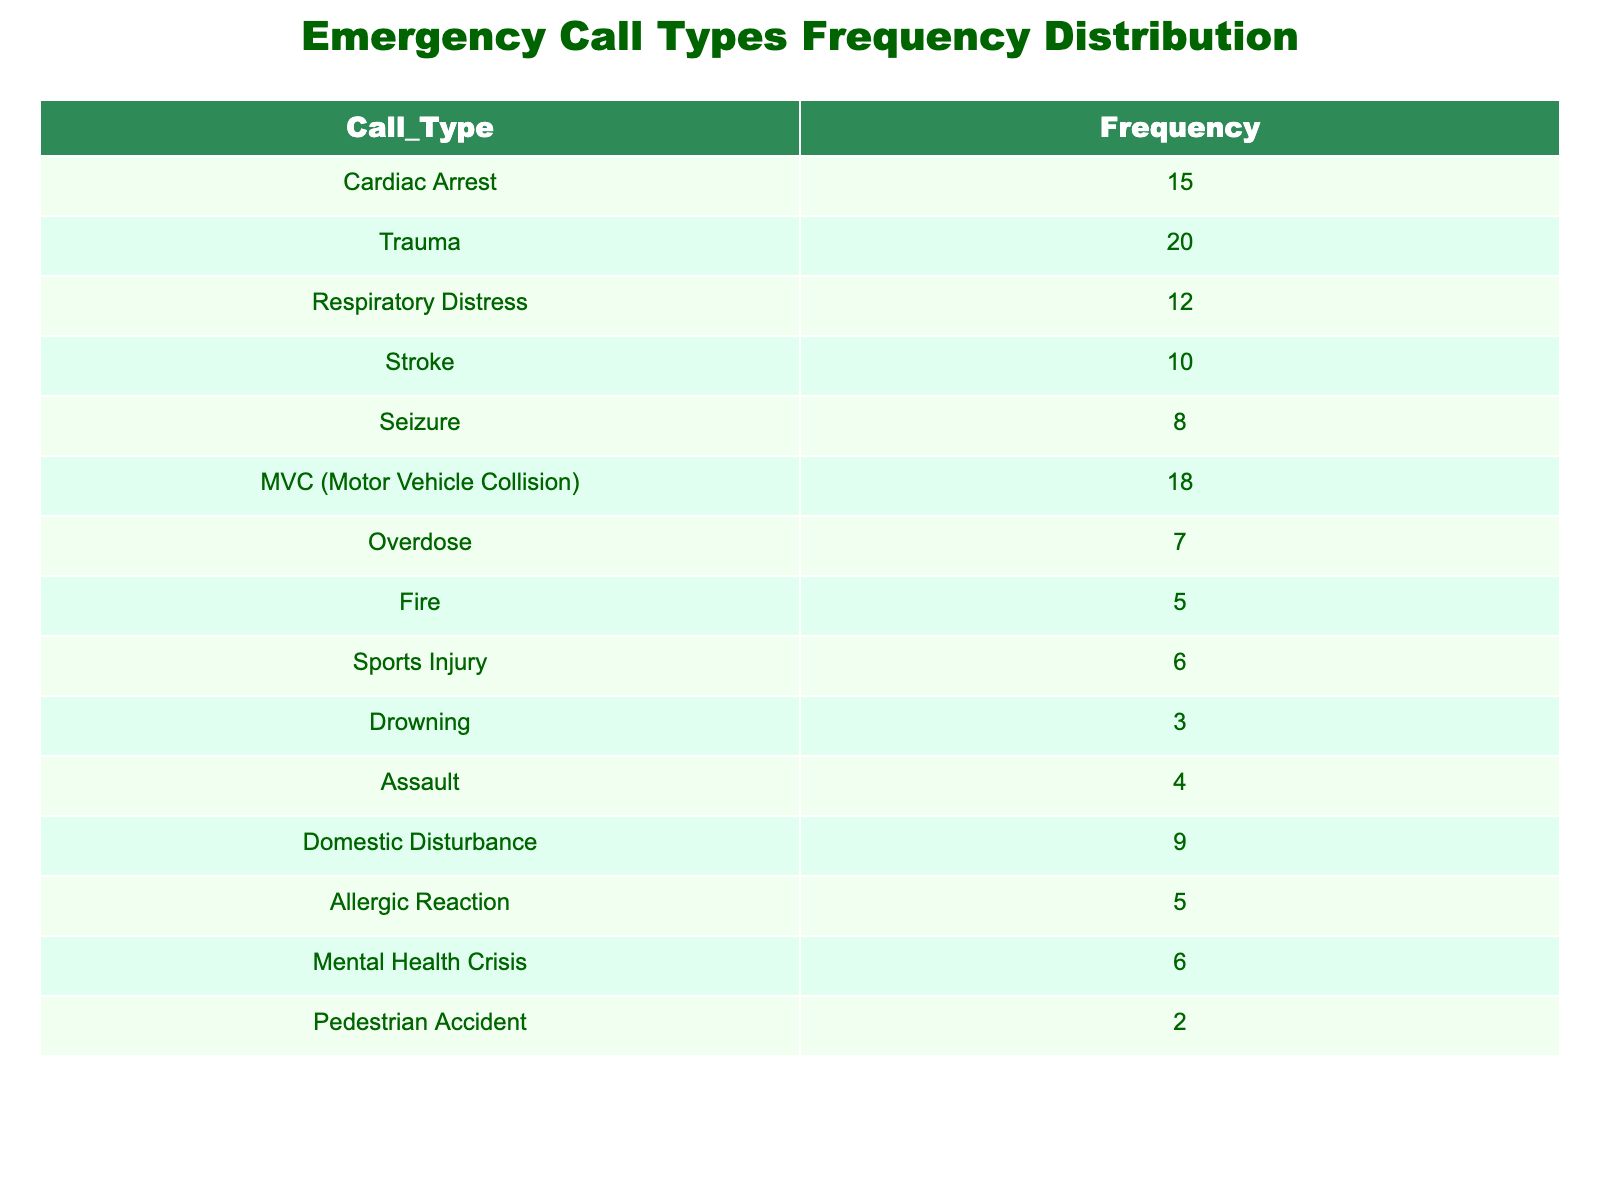What is the frequency of Trauma calls? The table lists the frequency of different call types. By locating the row for Trauma, we can see that the frequency is 20.
Answer: 20 How many calls were related to Mental Health Crisis? The table shows the frequency of each call type, and the row for Mental Health Crisis indicates a frequency of 6.
Answer: 6 What call type received the least number of calls? By examining the frequencies of all call types, Drowning has the lowest frequency at 3, making it the call type with the least number of calls.
Answer: Drowning What is the combined frequency of all Motor Vehicle Collisions (MVC) and Assault calls? To find the combined frequency, we add the frequencies of the two call types: MVC (18) + Assault (4) = 22.
Answer: 22 Is the frequency of Cardiac Arrest calls greater than the frequency of Stroke calls? The frequency of Cardiac Arrest is 15, while the frequency of Stroke is 10. Since 15 is greater than 10, the statement is true.
Answer: Yes What is the total number of calls received for all types listed in the table? To find the total number of calls, we need to sum all the frequencies: 15 (Cardiac Arrest) + 20 (Trauma) + 12 (Respiratory Distress) + 10 (Stroke) + 8 (Seizure) + 18 (MVC) + 7 (Overdose) + 5 (Fire) + 6 (Sports Injury) + 3 (Drowning) + 4 (Assault) + 9 (Domestic Disturbance) + 5 (Allergic Reaction) + 6 (Mental Health Crisis) + 2 (Pedestrian Accident) =  18 + 10 (16) + 14 (17) + 22 (90) + 7 (104) + 6 (14) = 70
Answer: 70 Which call type has a frequency that is exactly double that of Drowning? The Drowning call type has a frequency of 3. Looking through the other call types, Sports Injury has a frequency of 6, which is not double, and Assault has 4. Therefore, none of the other call types have a frequency that is double the Drowning frequency of 3.
Answer: No How many more calls did MVC have compared to Overdose? The MVC frequency is 18, and the Overdose frequency is 7. By calculating the difference, we find that MVC has 18 - 7 = 11 calls more than Overdose.
Answer: 11 What is the average number of calls for the types that fall under the category of "Injury" (Trauma, Sports Injury, MVC, Assault, Drowning, Pedestrian Accident)? To find the average, we first sum the frequencies of the injury-related call types: Trauma (20) + Sports Injury (6) + MVC (18) + Assault (4) + Drowning (3) + Pedestrian Accident (2) = 53. Then we divide that by the number of types (6): 53/6 ≈ 8.83.
Answer: Approximately 8.83 